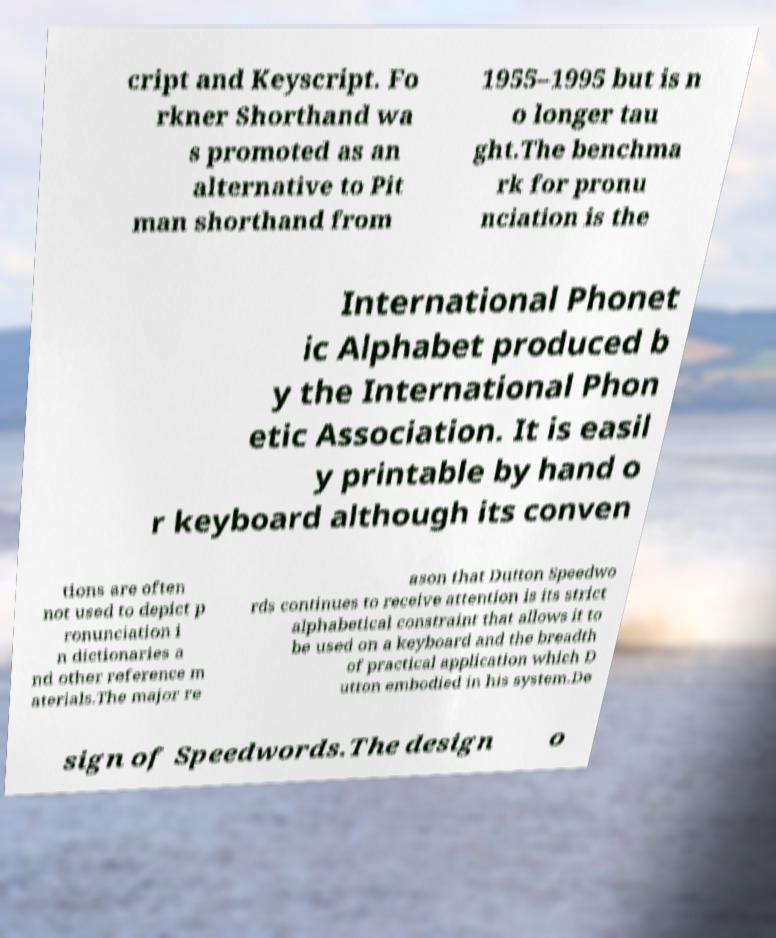What messages or text are displayed in this image? I need them in a readable, typed format. cript and Keyscript. Fo rkner Shorthand wa s promoted as an alternative to Pit man shorthand from 1955–1995 but is n o longer tau ght.The benchma rk for pronu nciation is the International Phonet ic Alphabet produced b y the International Phon etic Association. It is easil y printable by hand o r keyboard although its conven tions are often not used to depict p ronunciation i n dictionaries a nd other reference m aterials.The major re ason that Dutton Speedwo rds continues to receive attention is its strict alphabetical constraint that allows it to be used on a keyboard and the breadth of practical application which D utton embodied in his system.De sign of Speedwords.The design o 